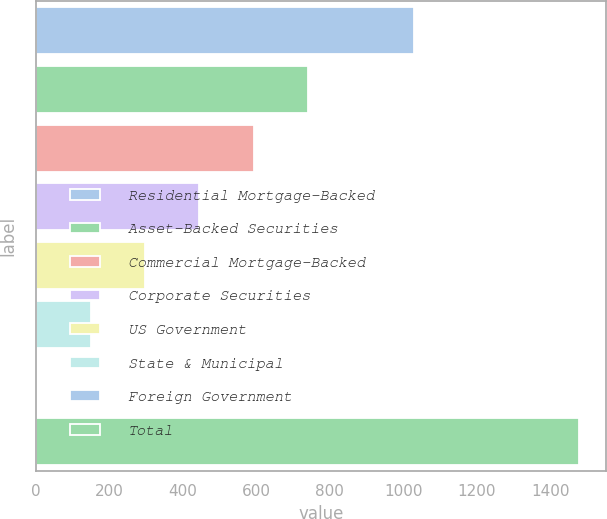Convert chart to OTSL. <chart><loc_0><loc_0><loc_500><loc_500><bar_chart><fcel>Residential Mortgage-Backed<fcel>Asset-Backed Securities<fcel>Commercial Mortgage-Backed<fcel>Corporate Securities<fcel>US Government<fcel>State & Municipal<fcel>Foreign Government<fcel>Total<nl><fcel>1029<fcel>740<fcel>592.2<fcel>444.4<fcel>296.6<fcel>148.8<fcel>1<fcel>1479<nl></chart> 